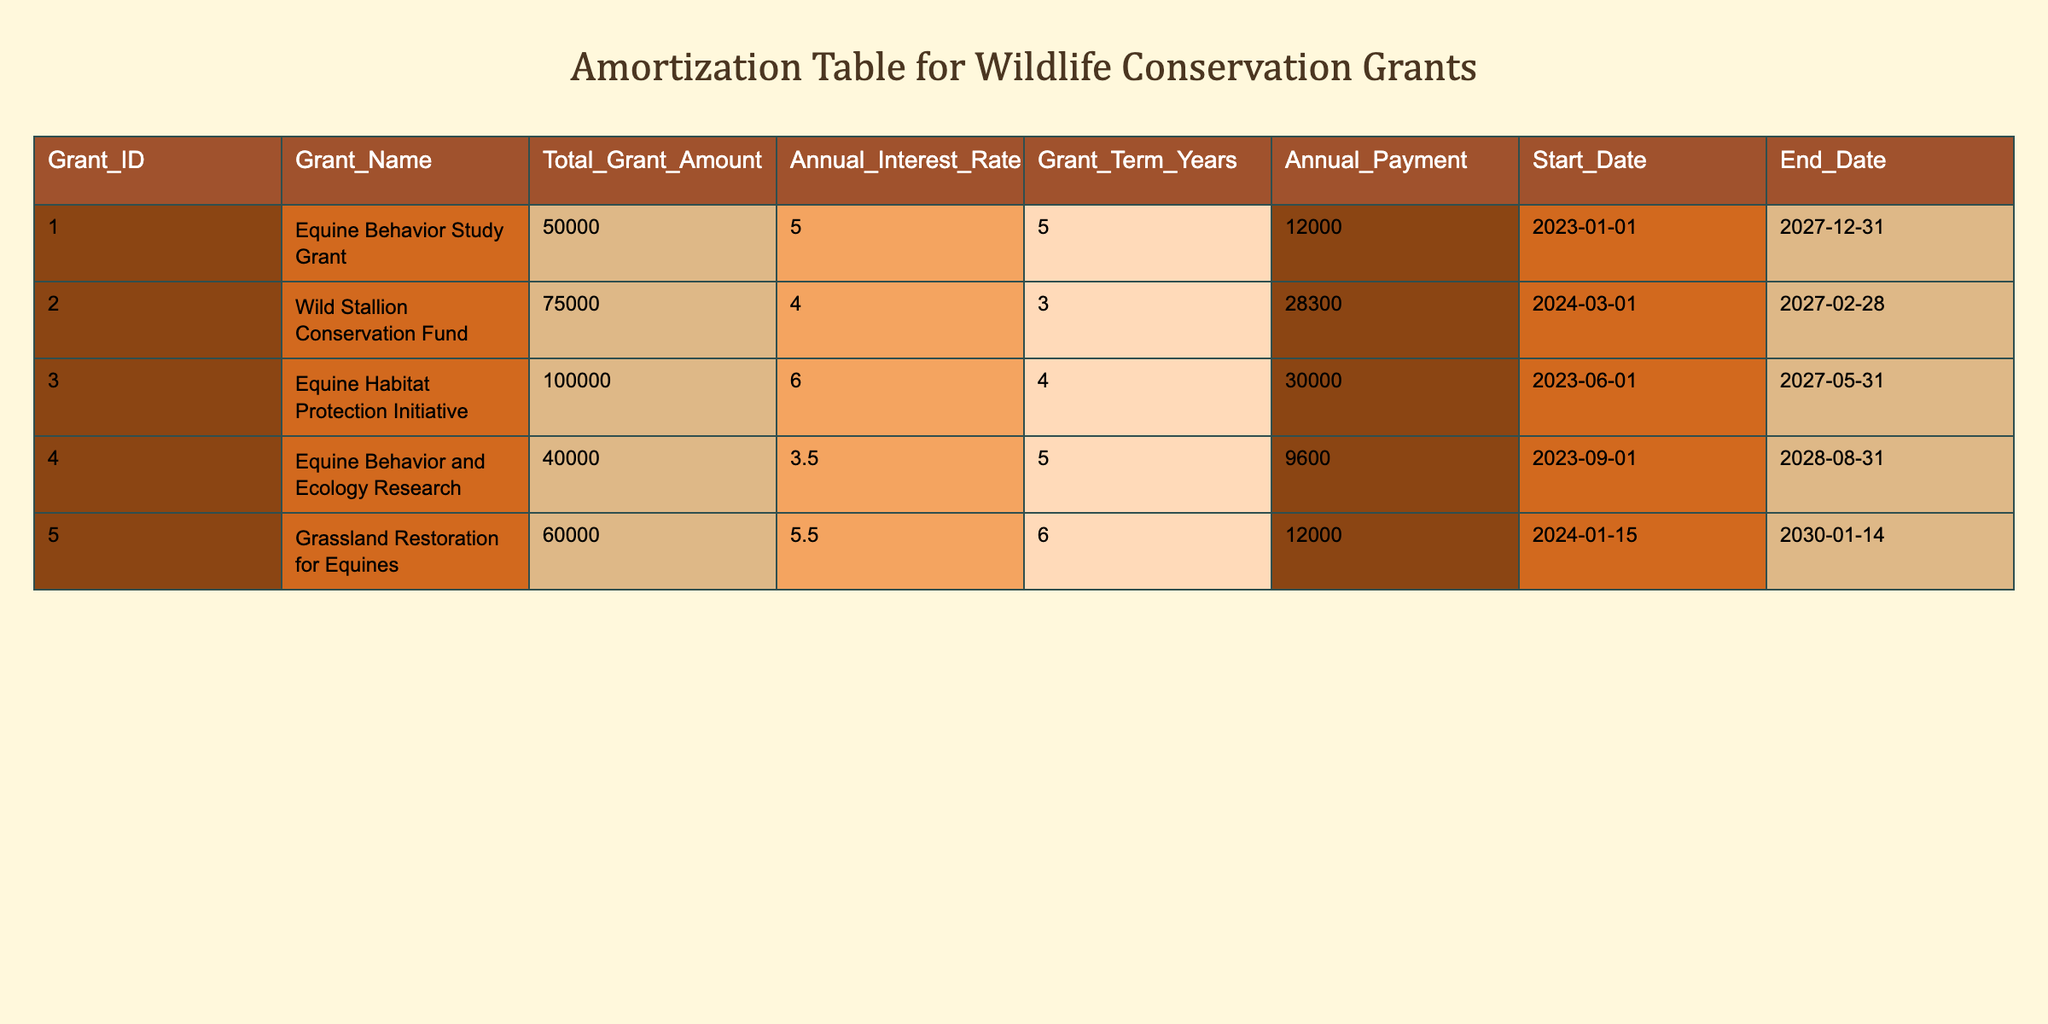What is the total grant amount for the Equine Habitat Protection Initiative? The table lists the total grant amount for each initiative. The specific row for the Equine Habitat Protection Initiative shows a total grant amount of 100,000.
Answer: 100000 What is the annual payment for the Wild Stallion Conservation Fund? Looking at the row for the Wild Stallion Conservation Fund, the annual payment is listed as 28,300.
Answer: 28300 Which grant has the longest term in years? Examining the Grant Term Years column, the Grassland Restoration for Equines has the longest term with 6 years.
Answer: Grassland Restoration for Equines Is the annual interest rate for the Equine Behavior and Ecology Research grant less than 4 percent? The table shows that the annual interest rate for the Equine Behavior and Ecology Research is 3.5 percent, which is indeed less than 4 percent.
Answer: Yes What are the total annual payments for all grants combined? To find the total, we need to add the annual payments: 12,000 + 28,300 + 30,000 + 9,600 + 12,000 = 91,900. Therefore, the total annual payments for all grants combined is 91,900.
Answer: 91900 How much more is the total grant amount of the Grassland Restoration for Equines than that of the Equine Behavior Study Grant? The Grassland Restoration for Equines has a total grant amount of 60,000 and the Equine Behavior Study Grant has 50,000. The difference is calculated as 60,000 - 50,000 = 10,000.
Answer: 10000 What is the average annual payment across all grants? To find the average, we sum the annual payments: 12,000 + 28,300 + 30,000 + 9,600 + 12,000 = 91,900, and then divide by the number of grants (5): 91,900 / 5 = 18,380.
Answer: 18380 Is the starting date for the Grassland Restoration for Equines grant earlier than January 1, 2024? The starting date for the Grassland Restoration for Equines grant is January 15, 2024, which is later than January 1, 2024.
Answer: No Which grant has a higher interest rate: the Equine Behavior Study Grant or the Equine Habitat Protection Initiative? The Equine Behavior Study Grant has an interest rate of 5 percent and the Equine Habitat Protection Initiative has an interest rate of 6 percent. Comparing the two shows that the Equine Habitat Protection Initiative has a higher interest rate.
Answer: Equine Habitat Protection Initiative 